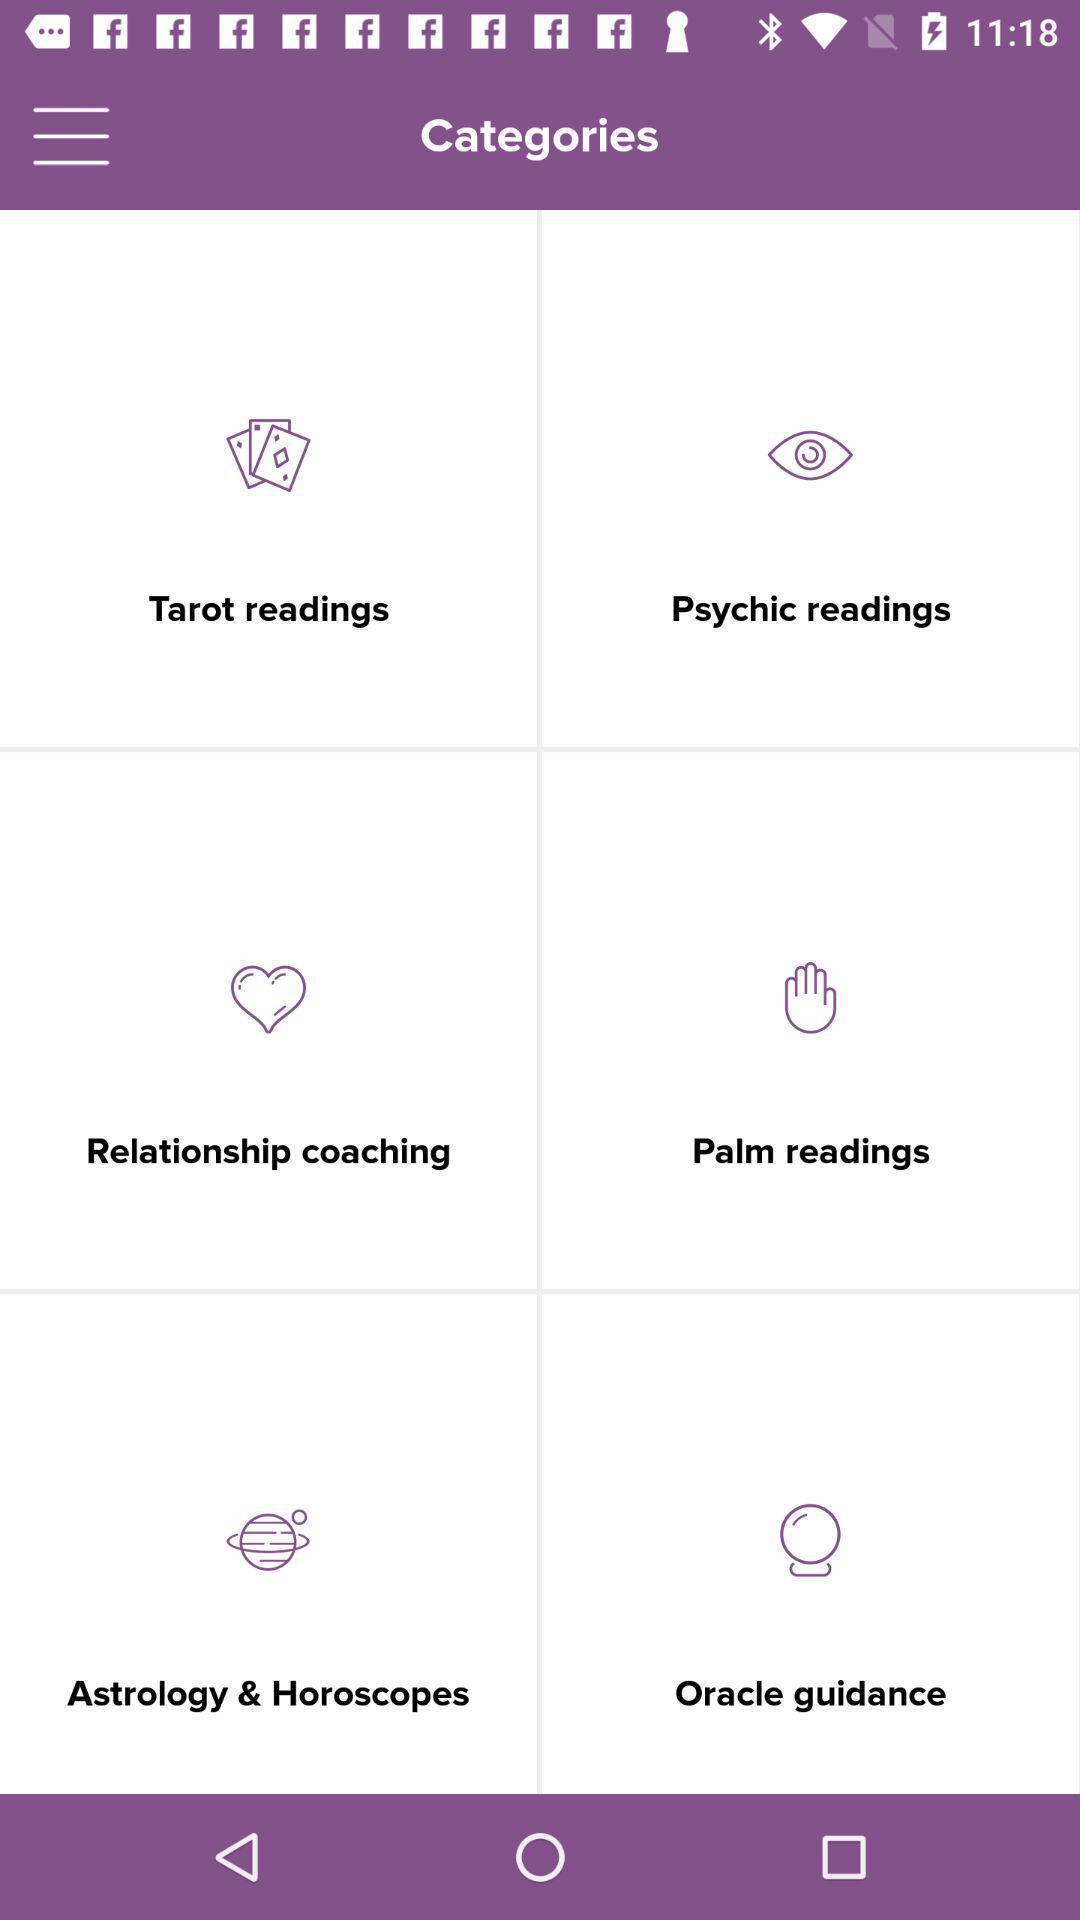Give me a narrative description of this picture. Starting page of an astrology app. 